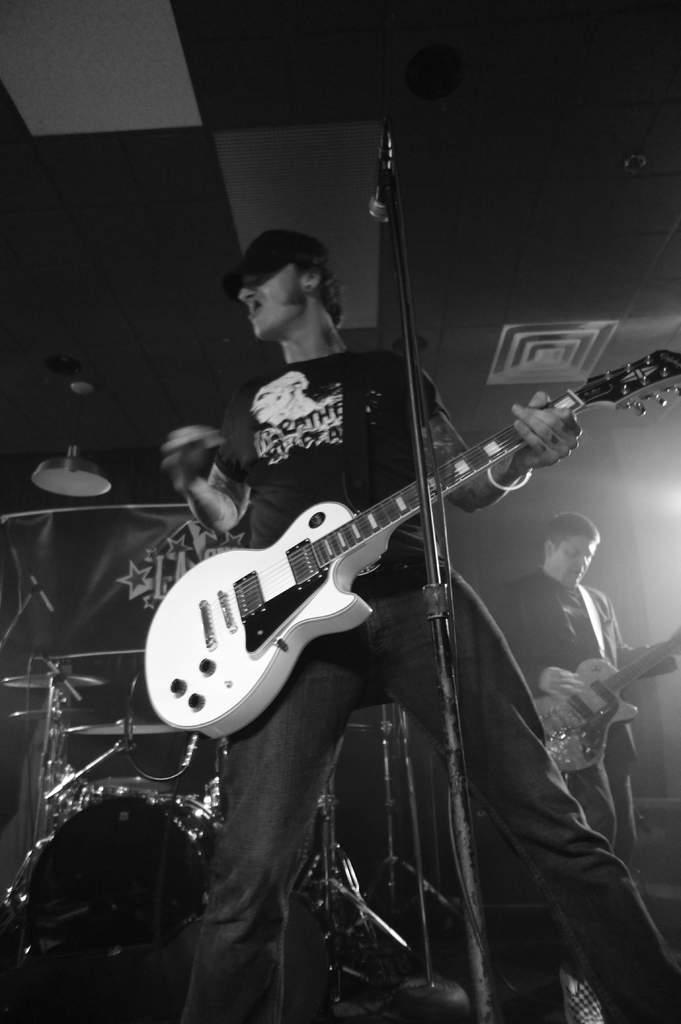How would you summarize this image in a sentence or two? In the middle of the image a man is standing and playing guitar and singing. Bottom right side of the image a man is playing guitar. Bottom left side of the image there are few drums. Top of the image there is a roof. In the middle of the image there is a microphone. 